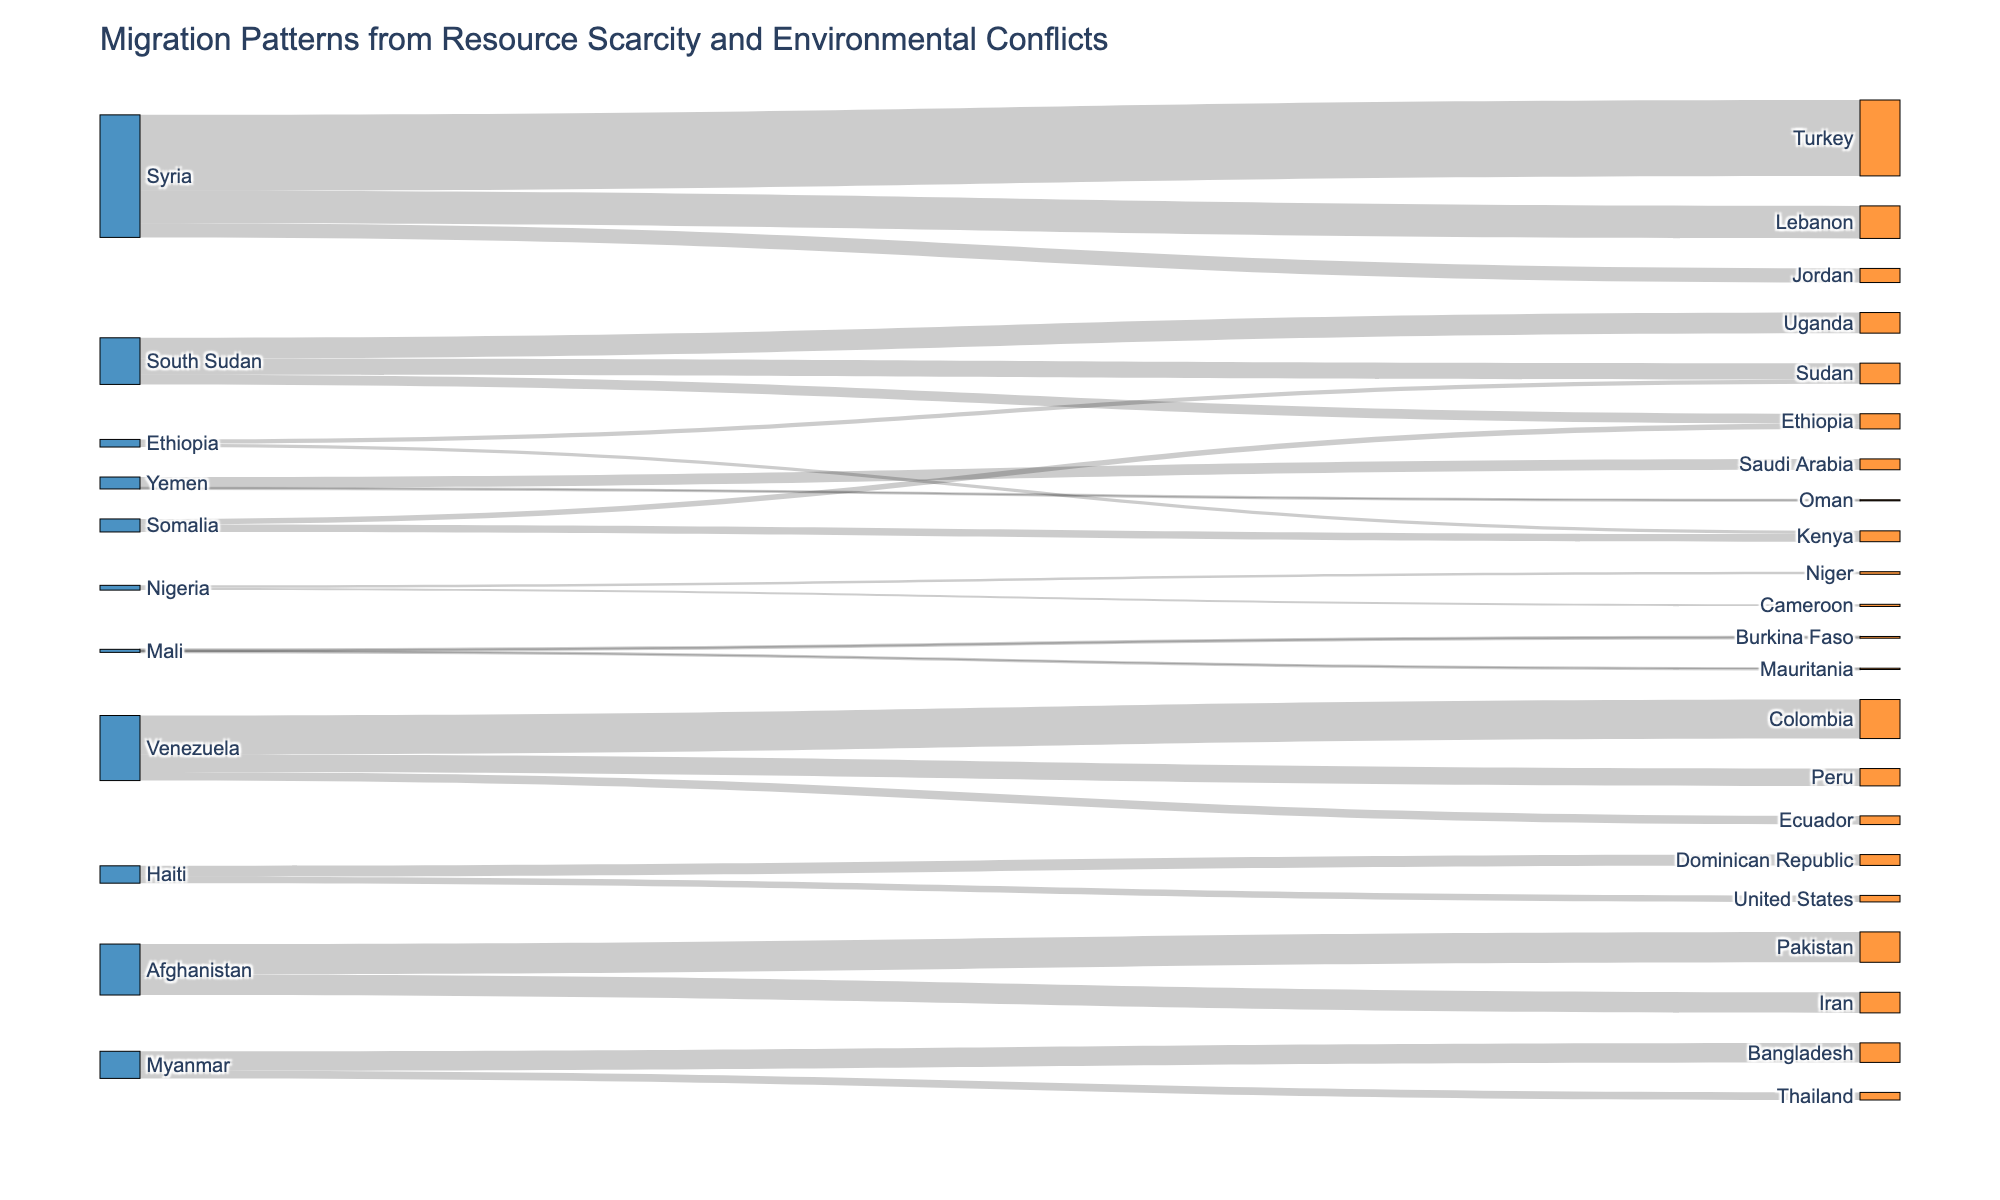How many countries are listed as sources of migration in the figure? Identify all unique source nodes in the Sankey diagram, which are countries from which migration originates. Count these countries.
Answer: 10 Which country has the highest migration flow and to which destination does it go? Look for the link with the largest value among the plotted links in the Sankey diagram. Identify the source country and its corresponding destination.
Answer: Syria to Turkey What is the combined migration flow from Syria to Turkey and Lebanon? Look at the migration values from Syria to Turkey and Lebanon. Sum the values to get the total. 3500000 (Syria to Turkey) + 1500000 (Syria to Lebanon) = 5000000
Answer: 5000000 How does the migration flow from Venezuela to Colombia compare to the flow from Venezuela to Peru? Compare the migration value from Venezuela to Colombia with the value from Venezuela to Peru. Note which is higher and the difference between them. 1800000 (Venezuela to Colombia) - 800000 (Venezuela to Peru) = 1000000 more migrants to Colombia
Answer: Higher by 1000000 Which destination country receives migrants from both Somalia and Ethiopia? Identify the common target nodes by checking which countries appear as targets for migrants from both Somalia and Ethiopia.
Answer: Kenya What is the total number of migrants flowing from Somalia mentioned in the diagram? Add the values of all migration flows originating from Somalia. 350000 (to Kenya) + 250000 (to Ethiopia) = 600000
Answer: 600000 Which source country has the least number of migrants flowing to one of its destinations? Compare the migration values of each link; identify the smallest migration value and its corresponding source. The smallest value is from Yemen to Oman which is 50000.
Answer: Yemen Are there countries that both send and receive migrants? If so, name one. Identify countries that appear in both the source and target nodes. Ethiopia appears as both source and target.
Answer: Ethiopia What is the flow from Afghanistan to Pakistan relative to the flow from Afghanistan to Iran? Compare the migration values from Afghanistan to Pakistan and from Afghanistan to Iran. 1400000 (to Pakistan) is roughly 1.5 times the value of 950000 (to Iran).
Answer: 1.5 times How many total migrants move from countries due to resource scarcity and environmental conflicts as visualized in the Sankey diagram? Sum all values of migration flows represented in the diagram. 3500000 + 1500000 + 650000 + 950000 + 750000 + 450000 + 500000 + 50000 + 350000 + 250000 + 200000 + 150000 + 120000 + 100000 + 80000 + 60000 + 1800000 + 800000 + 400000 + 500000 + 300000 + 1400000 + 950000 + 900000 + 350000 = 15320000
Answer: 15320000 